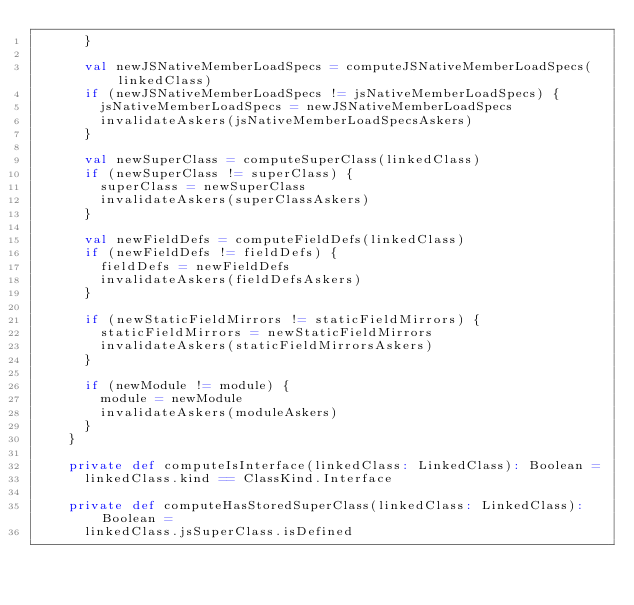<code> <loc_0><loc_0><loc_500><loc_500><_Scala_>      }

      val newJSNativeMemberLoadSpecs = computeJSNativeMemberLoadSpecs(linkedClass)
      if (newJSNativeMemberLoadSpecs != jsNativeMemberLoadSpecs) {
        jsNativeMemberLoadSpecs = newJSNativeMemberLoadSpecs
        invalidateAskers(jsNativeMemberLoadSpecsAskers)
      }

      val newSuperClass = computeSuperClass(linkedClass)
      if (newSuperClass != superClass) {
        superClass = newSuperClass
        invalidateAskers(superClassAskers)
      }

      val newFieldDefs = computeFieldDefs(linkedClass)
      if (newFieldDefs != fieldDefs) {
        fieldDefs = newFieldDefs
        invalidateAskers(fieldDefsAskers)
      }

      if (newStaticFieldMirrors != staticFieldMirrors) {
        staticFieldMirrors = newStaticFieldMirrors
        invalidateAskers(staticFieldMirrorsAskers)
      }

      if (newModule != module) {
        module = newModule
        invalidateAskers(moduleAskers)
      }
    }

    private def computeIsInterface(linkedClass: LinkedClass): Boolean =
      linkedClass.kind == ClassKind.Interface

    private def computeHasStoredSuperClass(linkedClass: LinkedClass): Boolean =
      linkedClass.jsSuperClass.isDefined
</code> 